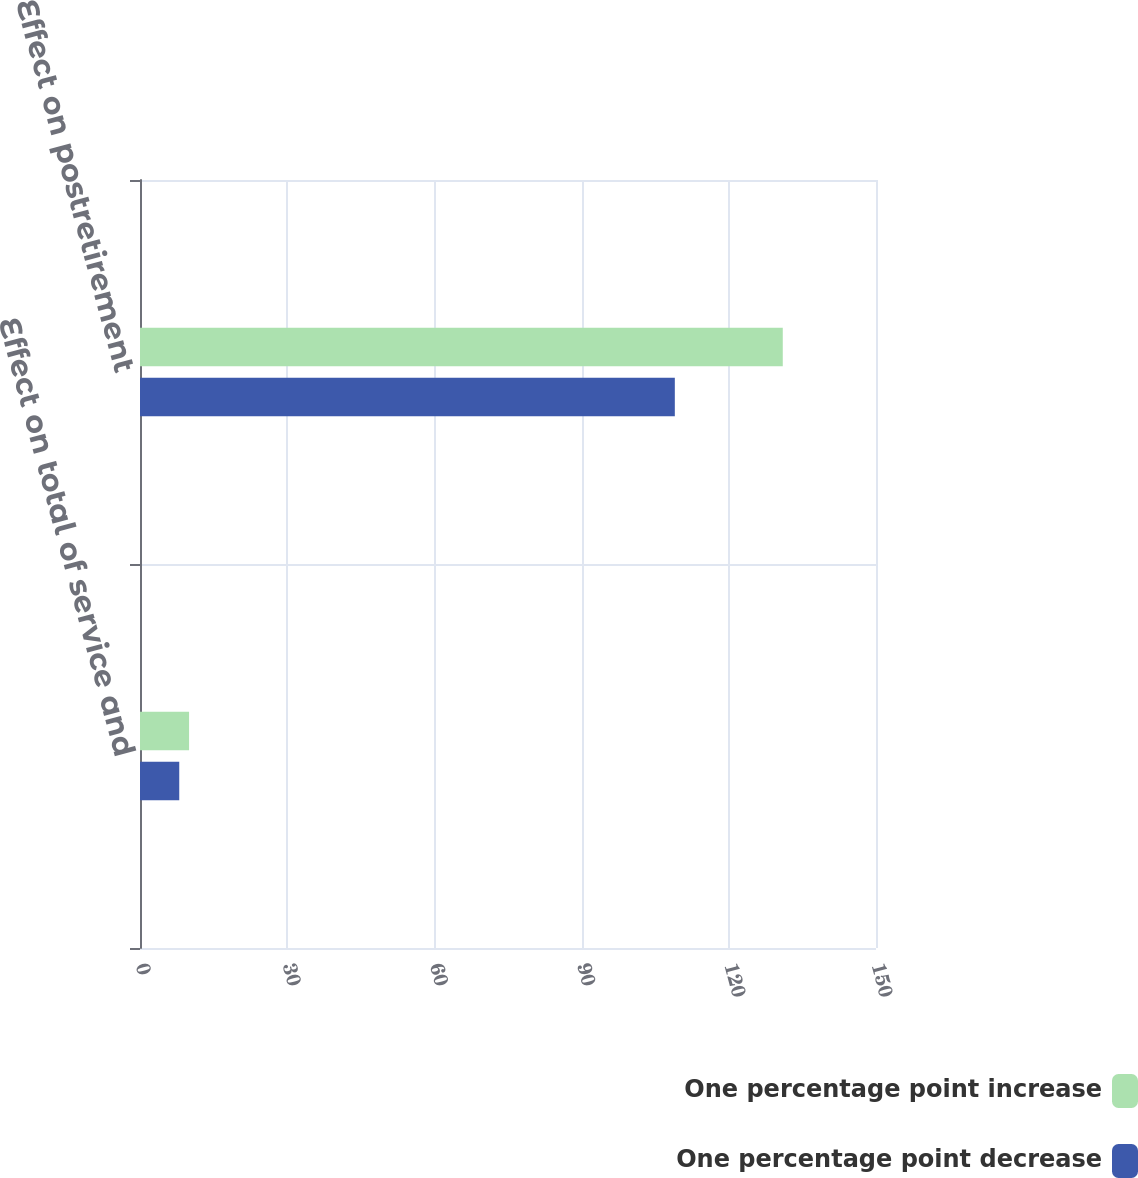Convert chart. <chart><loc_0><loc_0><loc_500><loc_500><stacked_bar_chart><ecel><fcel>Effect on total of service and<fcel>Effect on postretirement<nl><fcel>One percentage point increase<fcel>10<fcel>131<nl><fcel>One percentage point decrease<fcel>8<fcel>109<nl></chart> 